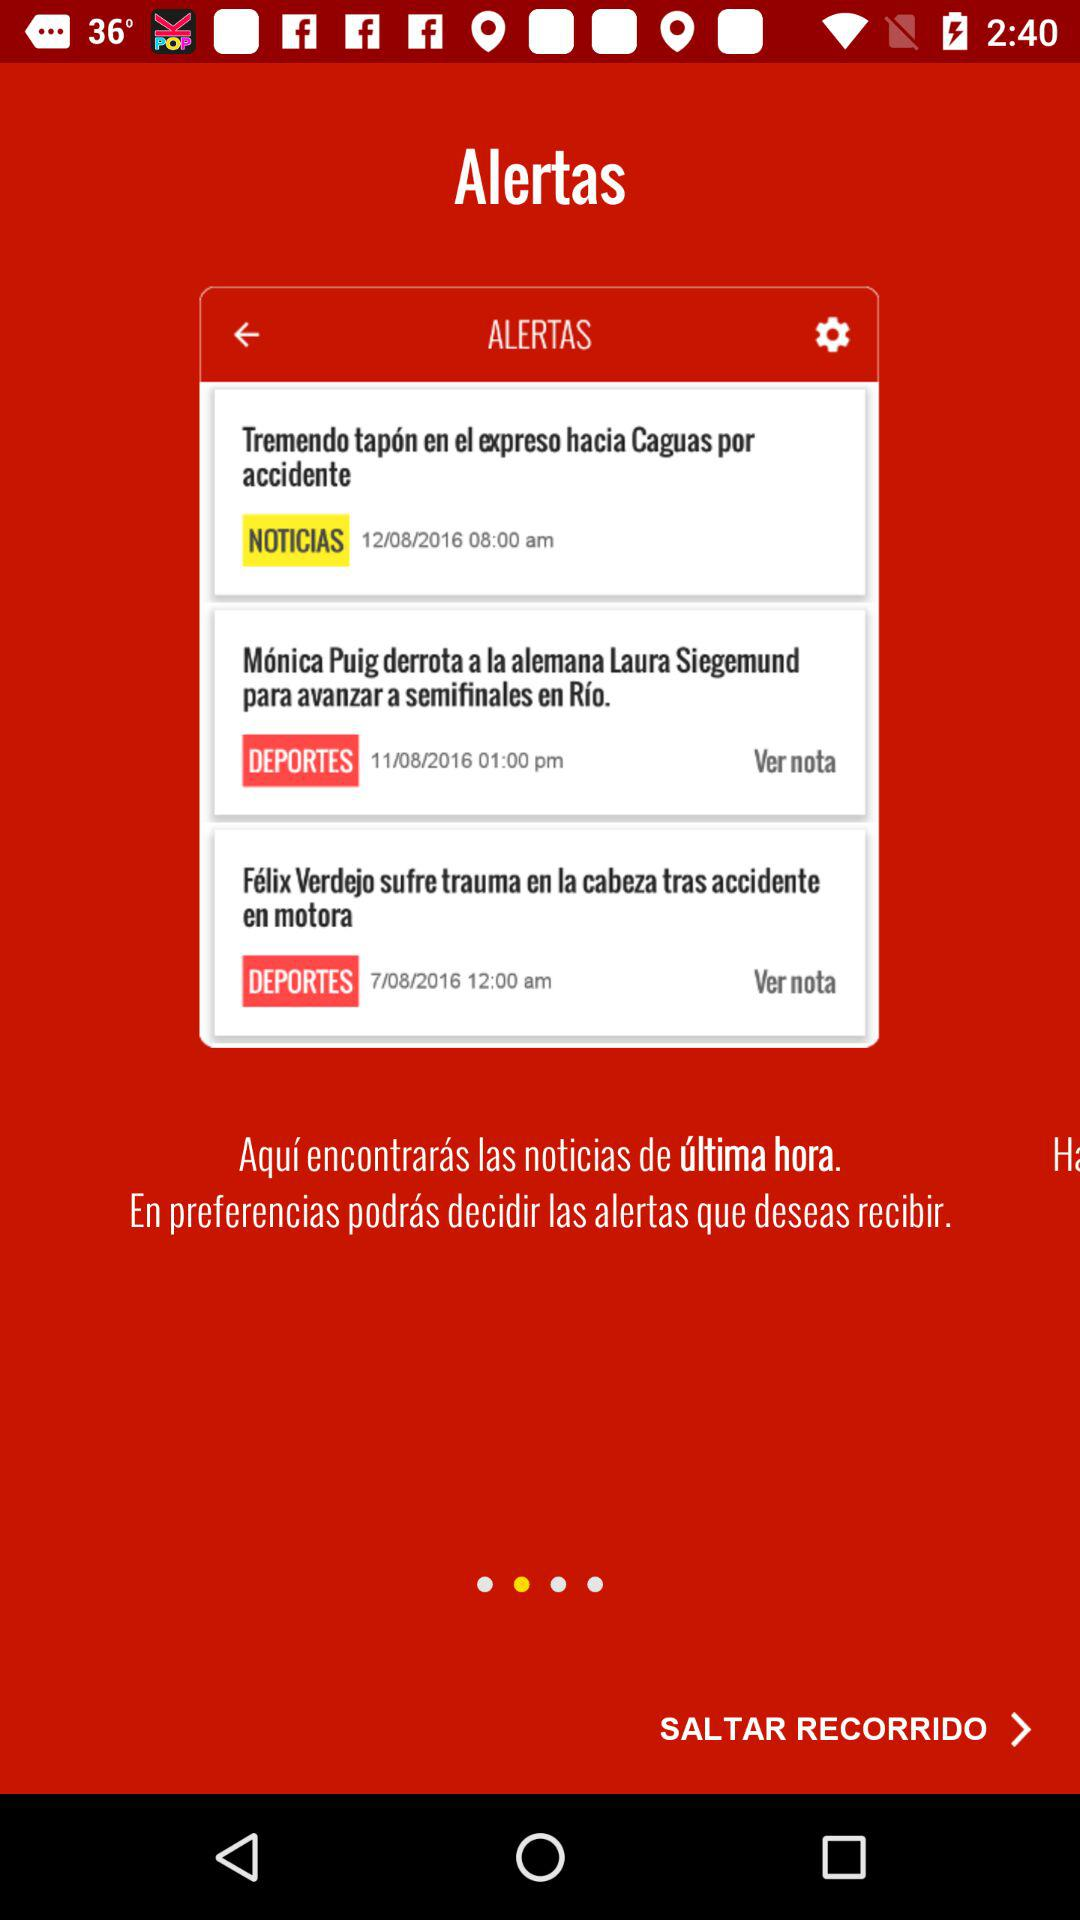How many news articles are there?
Answer the question using a single word or phrase. 3 